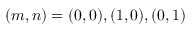<formula> <loc_0><loc_0><loc_500><loc_500>( m , n ) = ( 0 , 0 ) , ( 1 , 0 ) , ( 0 , 1 )</formula> 